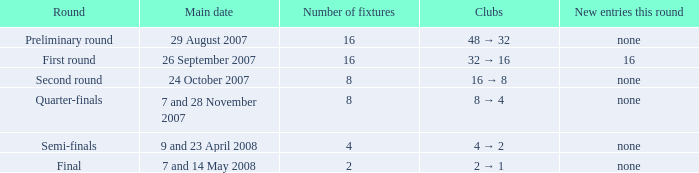For a round with more than two fixtures, what is the main date corresponding to 7th and 28th november 2007? Quarter-finals. 